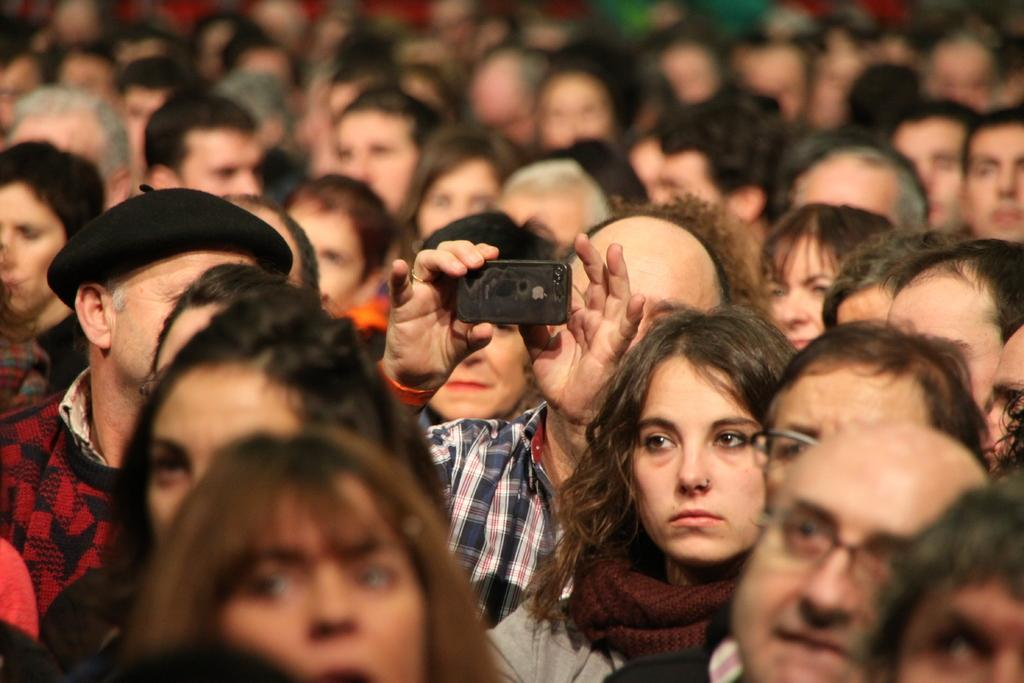How many people are in the image? There are many people in the image. What is the man in the center doing? The man in the center is holding a mobile phone in his hand. Can you describe the man standing beside him? The second man is wearing a hat. How many elbows can be seen in the image? The number of elbows cannot be determined from the provided facts, as they do not mention the position or posture of the people in the image. Are any of the people running in the image? There is no information about people running in the image, as the provided facts only mention the presence of a mobile phone and a hat. 